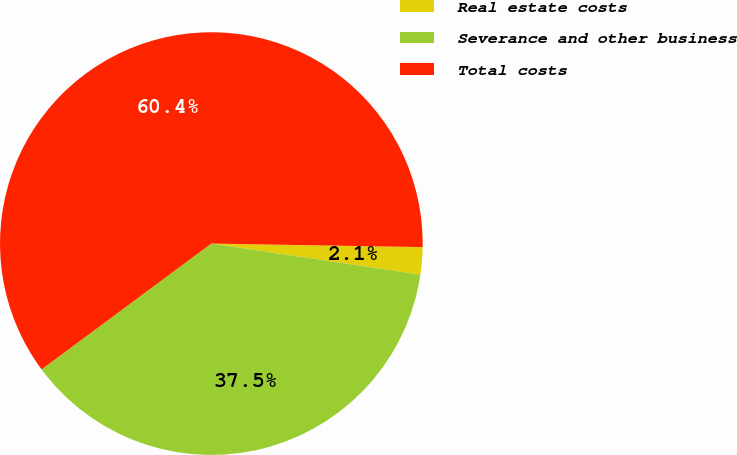Convert chart. <chart><loc_0><loc_0><loc_500><loc_500><pie_chart><fcel>Real estate costs<fcel>Severance and other business<fcel>Total costs<nl><fcel>2.08%<fcel>37.5%<fcel>60.42%<nl></chart> 